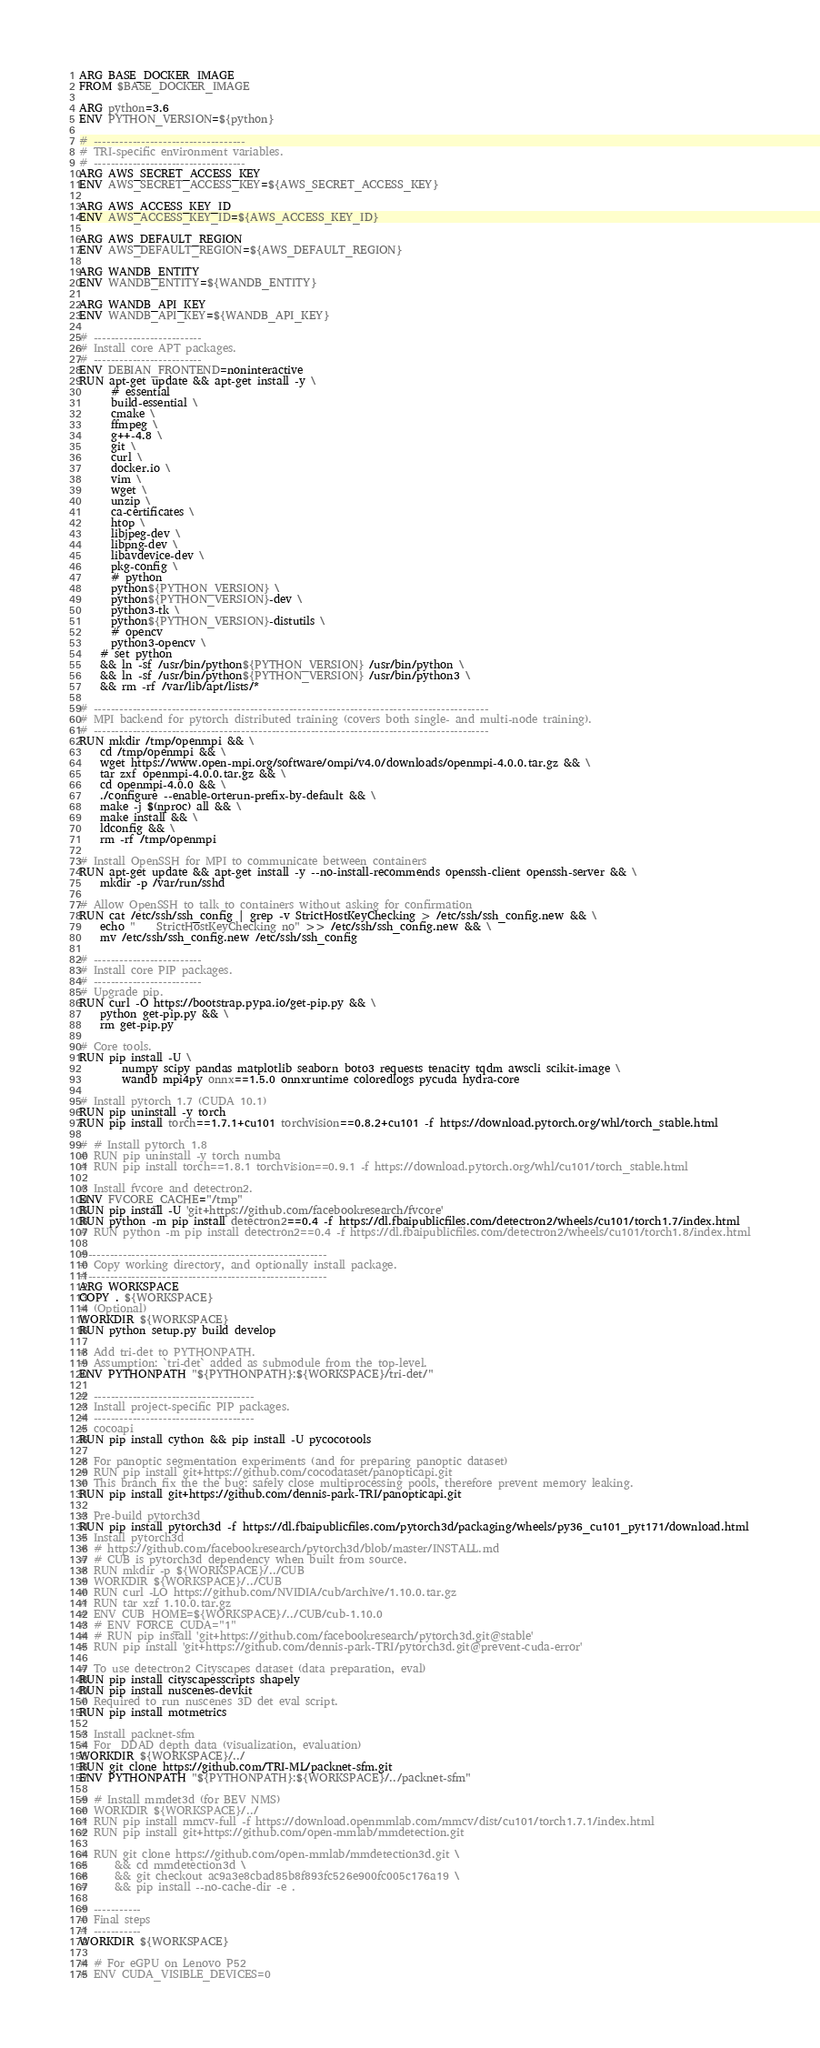Convert code to text. <code><loc_0><loc_0><loc_500><loc_500><_Dockerfile_>ARG BASE_DOCKER_IMAGE
FROM $BASE_DOCKER_IMAGE

ARG python=3.6
ENV PYTHON_VERSION=${python}

# -----------------------------------
# TRI-specific environment variables.
# -----------------------------------
ARG AWS_SECRET_ACCESS_KEY
ENV AWS_SECRET_ACCESS_KEY=${AWS_SECRET_ACCESS_KEY}

ARG AWS_ACCESS_KEY_ID
ENV AWS_ACCESS_KEY_ID=${AWS_ACCESS_KEY_ID}

ARG AWS_DEFAULT_REGION
ENV AWS_DEFAULT_REGION=${AWS_DEFAULT_REGION}

ARG WANDB_ENTITY
ENV WANDB_ENTITY=${WANDB_ENTITY}

ARG WANDB_API_KEY
ENV WANDB_API_KEY=${WANDB_API_KEY}

# -------------------------
# Install core APT packages.
# -------------------------
ENV DEBIAN_FRONTEND=noninteractive
RUN apt-get update && apt-get install -y \
      # essential
      build-essential \
      cmake \
      ffmpeg \
      g++-4.8 \
      git \
      curl \
      docker.io \
      vim \
      wget \
      unzip \
      ca-certificates \
      htop \
      libjpeg-dev \
      libpng-dev \
      libavdevice-dev \
      pkg-config \
      # python
      python${PYTHON_VERSION} \
      python${PYTHON_VERSION}-dev \
      python3-tk \
      python${PYTHON_VERSION}-distutils \
      # opencv
      python3-opencv \
    # set python
    && ln -sf /usr/bin/python${PYTHON_VERSION} /usr/bin/python \
    && ln -sf /usr/bin/python${PYTHON_VERSION} /usr/bin/python3 \
    && rm -rf /var/lib/apt/lists/*

# -------------------------------------------------------------------------------------------
# MPI backend for pytorch distributed training (covers both single- and multi-node training).
# -------------------------------------------------------------------------------------------
RUN mkdir /tmp/openmpi && \
    cd /tmp/openmpi && \
    wget https://www.open-mpi.org/software/ompi/v4.0/downloads/openmpi-4.0.0.tar.gz && \
    tar zxf openmpi-4.0.0.tar.gz && \
    cd openmpi-4.0.0 && \
    ./configure --enable-orterun-prefix-by-default && \
    make -j $(nproc) all && \
    make install && \
    ldconfig && \
    rm -rf /tmp/openmpi

# Install OpenSSH for MPI to communicate between containers
RUN apt-get update && apt-get install -y --no-install-recommends openssh-client openssh-server && \
    mkdir -p /var/run/sshd

# Allow OpenSSH to talk to containers without asking for confirmation
RUN cat /etc/ssh/ssh_config | grep -v StrictHostKeyChecking > /etc/ssh/ssh_config.new && \
    echo "    StrictHostKeyChecking no" >> /etc/ssh/ssh_config.new && \
    mv /etc/ssh/ssh_config.new /etc/ssh/ssh_config

# -------------------------
# Install core PIP packages.
# -------------------------
# Upgrade pip.
RUN curl -O https://bootstrap.pypa.io/get-pip.py && \
    python get-pip.py && \
    rm get-pip.py

# Core tools.
RUN pip install -U \
        numpy scipy pandas matplotlib seaborn boto3 requests tenacity tqdm awscli scikit-image \
        wandb mpi4py onnx==1.5.0 onnxruntime coloredlogs pycuda hydra-core

# Install pytorch 1.7 (CUDA 10.1)
RUN pip uninstall -y torch
RUN pip install torch==1.7.1+cu101 torchvision==0.8.2+cu101 -f https://download.pytorch.org/whl/torch_stable.html

# # Install pytorch 1.8
# RUN pip uninstall -y torch numba
# RUN pip install torch==1.8.1 torchvision==0.9.1 -f https://download.pytorch.org/whl/cu101/torch_stable.html

# Install fvcore and detectron2.
ENV FVCORE_CACHE="/tmp"
RUN pip install -U 'git+https://github.com/facebookresearch/fvcore'
RUN python -m pip install detectron2==0.4 -f https://dl.fbaipublicfiles.com/detectron2/wheels/cu101/torch1.7/index.html
# RUN python -m pip install detectron2==0.4 -f https://dl.fbaipublicfiles.com/detectron2/wheels/cu101/torch1.8/index.html

#-------------------------------------------------------
# Copy working directory, and optionally install package.
#-------------------------------------------------------
ARG WORKSPACE
COPY . ${WORKSPACE}
# (Optional)
WORKDIR ${WORKSPACE}
RUN python setup.py build develop

# Add tri-det to PYTHONPATH.
# Assumption: `tri-det` added as submodule from the top-level.
ENV PYTHONPATH "${PYTHONPATH}:${WORKSPACE}/tri-det/"

# -------------------------------------
# Install project-specific PIP packages.
# -------------------------------------
# cocoapi
RUN pip install cython && pip install -U pycocotools

# For panoptic segmentation experiments (and for preparing panoptic dataset)
# RUN pip install git+https://github.com/cocodataset/panopticapi.git
# This branch fix the the bug: safely close multiprocessing pools, therefore prevent memory leaking.
RUN pip install git+https://github.com/dennis-park-TRI/panopticapi.git

# Pre-build pytorch3d
RUN pip install pytorch3d -f https://dl.fbaipublicfiles.com/pytorch3d/packaging/wheels/py36_cu101_pyt171/download.html
# Install pytorch3d
# # https://github.com/facebookresearch/pytorch3d/blob/master/INSTALL.md
# # CUB is pytorch3d dependency when built from source.
# RUN mkdir -p ${WORKSPACE}/../CUB
# WORKDIR ${WORKSPACE}/../CUB
# RUN curl -LO https://github.com/NVIDIA/cub/archive/1.10.0.tar.gz
# RUN tar xzf 1.10.0.tar.gz
# ENV CUB_HOME=${WORKSPACE}/../CUB/cub-1.10.0
# # ENV FORCE_CUDA="1"
# # RUN pip install 'git+https://github.com/facebookresearch/pytorch3d.git@stable'
# RUN pip install 'git+https://github.com/dennis-park-TRI/pytorch3d.git@prevent-cuda-error'

# To use detectron2 Cityscapes dataset (data preparation, eval)
RUN pip install cityscapesscripts shapely
RUN pip install nuscenes-devkit
# Required to run nuscenes 3D det eval script.
RUN pip install motmetrics

# Install packnet-sfm
# For  DDAD depth data (visualization, evaluation)
WORKDIR ${WORKSPACE}/../
RUN git clone https://github.com/TRI-ML/packnet-sfm.git
ENV PYTHONPATH "${PYTHONPATH}:${WORKSPACE}/../packnet-sfm"

# # Install mmdet3d (for BEV NMS)
# WORKDIR ${WORKSPACE}/../
# RUN pip install mmcv-full -f https://download.openmmlab.com/mmcv/dist/cu101/torch1.7.1/index.html
# RUN pip install git+https://github.com/open-mmlab/mmdetection.git

# RUN git clone https://github.com/open-mmlab/mmdetection3d.git \
#     && cd mmdetection3d \
#     && git checkout ac9a3e8cbad85b8f893fc526e900fc005c176a19 \
#     && pip install --no-cache-dir -e .

# -----------
# Final steps
# -----------
WORKDIR ${WORKSPACE}

# # For eGPU on Lenovo P52
# ENV CUDA_VISIBLE_DEVICES=0
</code> 